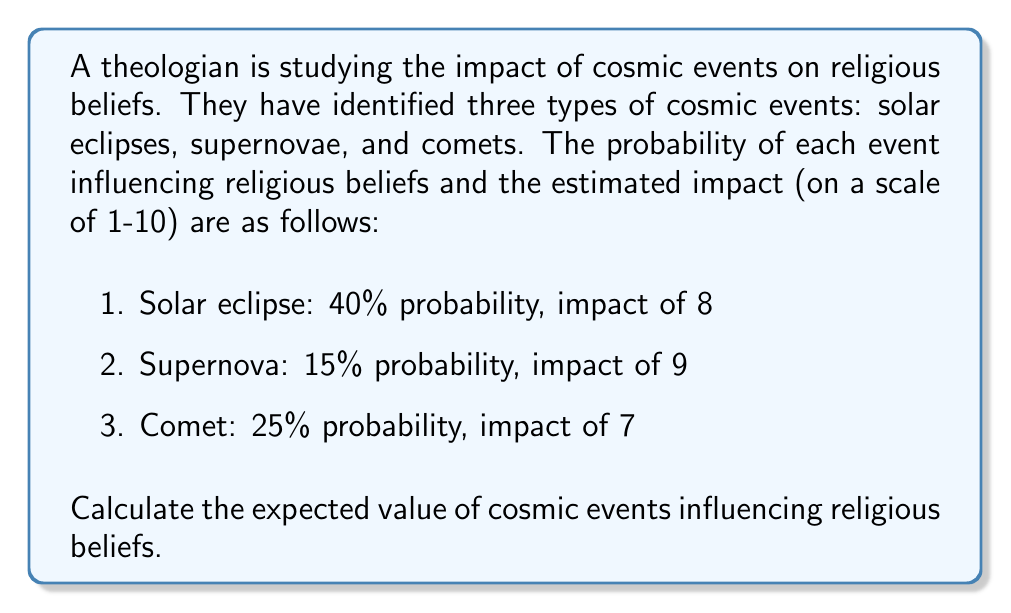Show me your answer to this math problem. To calculate the expected value, we need to follow these steps:

1. Identify the probability and impact (value) for each event:
   - Solar eclipse: $p_1 = 0.40$, $v_1 = 8$
   - Supernova: $p_2 = 0.15$, $v_2 = 9$
   - Comet: $p_3 = 0.25$, $v_3 = 7$

2. Calculate the expected value for each event using the formula:
   $E(X_i) = p_i \times v_i$

   Solar eclipse: $E(X_1) = 0.40 \times 8 = 3.20$
   Supernova: $E(X_2) = 0.15 \times 9 = 1.35$
   Comet: $E(X_3) = 0.25 \times 7 = 1.75$

3. Sum up the individual expected values to get the total expected value:

   $$E(X) = E(X_1) + E(X_2) + E(X_3)$$
   $$E(X) = 3.20 + 1.35 + 1.75 = 6.30$$

Therefore, the expected value of cosmic events influencing religious beliefs is 6.30.
Answer: $6.30$ 